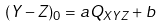<formula> <loc_0><loc_0><loc_500><loc_500>( Y - Z ) _ { 0 } = a Q _ { X Y Z } + b</formula> 